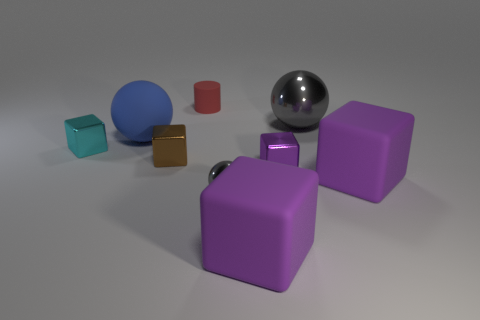There is a small cyan shiny thing; are there any large things in front of it?
Keep it short and to the point. Yes. What number of other tiny metal things have the same shape as the small cyan metallic thing?
Make the answer very short. 2. Are the large blue sphere and the small thing that is behind the cyan metallic cube made of the same material?
Give a very brief answer. Yes. How many blue objects are there?
Your answer should be very brief. 1. How big is the gray object that is in front of the brown thing?
Provide a short and direct response. Small. What number of cubes are the same size as the cylinder?
Your answer should be very brief. 3. What is the material of the block that is to the left of the red rubber cylinder and to the right of the small cyan thing?
Offer a terse response. Metal. What is the material of the red cylinder that is the same size as the cyan block?
Offer a very short reply. Rubber. There is a gray object that is to the left of the gray metal thing on the right side of the large purple matte block on the left side of the purple metallic thing; what size is it?
Ensure brevity in your answer.  Small. There is another sphere that is made of the same material as the tiny gray sphere; what is its size?
Your answer should be compact. Large. 